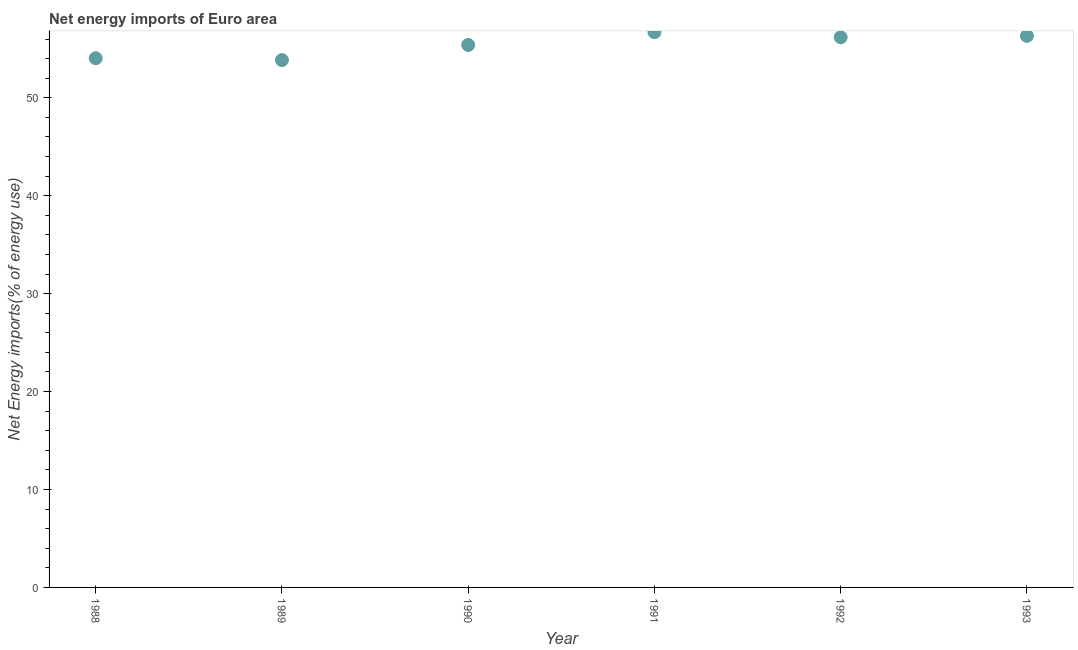What is the energy imports in 1990?
Your response must be concise. 55.39. Across all years, what is the maximum energy imports?
Your response must be concise. 56.7. Across all years, what is the minimum energy imports?
Give a very brief answer. 53.85. In which year was the energy imports minimum?
Give a very brief answer. 1989. What is the sum of the energy imports?
Your answer should be compact. 332.48. What is the difference between the energy imports in 1989 and 1991?
Offer a terse response. -2.85. What is the average energy imports per year?
Your response must be concise. 55.41. What is the median energy imports?
Give a very brief answer. 55.79. In how many years, is the energy imports greater than 46 %?
Give a very brief answer. 6. Do a majority of the years between 1993 and 1988 (inclusive) have energy imports greater than 42 %?
Make the answer very short. Yes. What is the ratio of the energy imports in 1988 to that in 1989?
Keep it short and to the point. 1. Is the energy imports in 1989 less than that in 1990?
Provide a short and direct response. Yes. What is the difference between the highest and the second highest energy imports?
Offer a terse response. 0.37. Is the sum of the energy imports in 1988 and 1992 greater than the maximum energy imports across all years?
Ensure brevity in your answer.  Yes. What is the difference between the highest and the lowest energy imports?
Your answer should be compact. 2.85. In how many years, is the energy imports greater than the average energy imports taken over all years?
Your response must be concise. 3. Does the energy imports monotonically increase over the years?
Provide a short and direct response. No. How many dotlines are there?
Ensure brevity in your answer.  1. Does the graph contain any zero values?
Ensure brevity in your answer.  No. What is the title of the graph?
Your answer should be compact. Net energy imports of Euro area. What is the label or title of the X-axis?
Ensure brevity in your answer.  Year. What is the label or title of the Y-axis?
Ensure brevity in your answer.  Net Energy imports(% of energy use). What is the Net Energy imports(% of energy use) in 1988?
Your answer should be very brief. 54.04. What is the Net Energy imports(% of energy use) in 1989?
Provide a short and direct response. 53.85. What is the Net Energy imports(% of energy use) in 1990?
Provide a short and direct response. 55.39. What is the Net Energy imports(% of energy use) in 1991?
Ensure brevity in your answer.  56.7. What is the Net Energy imports(% of energy use) in 1992?
Provide a succinct answer. 56.18. What is the Net Energy imports(% of energy use) in 1993?
Your response must be concise. 56.32. What is the difference between the Net Energy imports(% of energy use) in 1988 and 1989?
Keep it short and to the point. 0.19. What is the difference between the Net Energy imports(% of energy use) in 1988 and 1990?
Give a very brief answer. -1.35. What is the difference between the Net Energy imports(% of energy use) in 1988 and 1991?
Provide a succinct answer. -2.66. What is the difference between the Net Energy imports(% of energy use) in 1988 and 1992?
Offer a very short reply. -2.14. What is the difference between the Net Energy imports(% of energy use) in 1988 and 1993?
Offer a terse response. -2.29. What is the difference between the Net Energy imports(% of energy use) in 1989 and 1990?
Make the answer very short. -1.54. What is the difference between the Net Energy imports(% of energy use) in 1989 and 1991?
Your answer should be very brief. -2.85. What is the difference between the Net Energy imports(% of energy use) in 1989 and 1992?
Keep it short and to the point. -2.33. What is the difference between the Net Energy imports(% of energy use) in 1989 and 1993?
Your answer should be compact. -2.48. What is the difference between the Net Energy imports(% of energy use) in 1990 and 1991?
Your answer should be very brief. -1.3. What is the difference between the Net Energy imports(% of energy use) in 1990 and 1992?
Offer a terse response. -0.79. What is the difference between the Net Energy imports(% of energy use) in 1990 and 1993?
Give a very brief answer. -0.93. What is the difference between the Net Energy imports(% of energy use) in 1991 and 1992?
Give a very brief answer. 0.51. What is the difference between the Net Energy imports(% of energy use) in 1991 and 1993?
Your answer should be very brief. 0.37. What is the difference between the Net Energy imports(% of energy use) in 1992 and 1993?
Offer a terse response. -0.14. What is the ratio of the Net Energy imports(% of energy use) in 1988 to that in 1990?
Your answer should be very brief. 0.98. What is the ratio of the Net Energy imports(% of energy use) in 1988 to that in 1991?
Give a very brief answer. 0.95. What is the ratio of the Net Energy imports(% of energy use) in 1989 to that in 1992?
Ensure brevity in your answer.  0.96. What is the ratio of the Net Energy imports(% of energy use) in 1989 to that in 1993?
Keep it short and to the point. 0.96. What is the ratio of the Net Energy imports(% of energy use) in 1990 to that in 1991?
Keep it short and to the point. 0.98. What is the ratio of the Net Energy imports(% of energy use) in 1991 to that in 1992?
Make the answer very short. 1.01. What is the ratio of the Net Energy imports(% of energy use) in 1992 to that in 1993?
Offer a terse response. 1. 